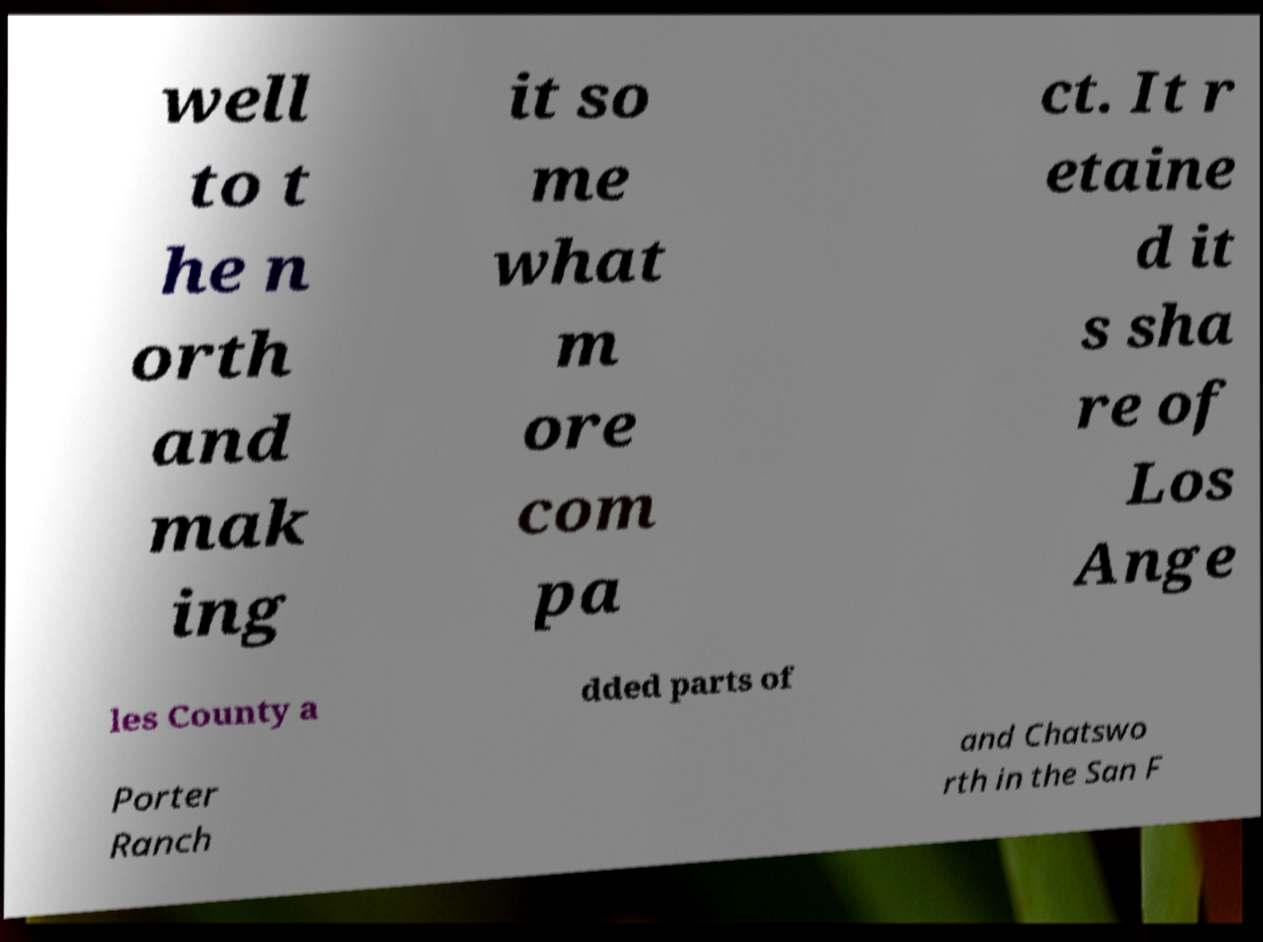Can you accurately transcribe the text from the provided image for me? well to t he n orth and mak ing it so me what m ore com pa ct. It r etaine d it s sha re of Los Ange les County a dded parts of Porter Ranch and Chatswo rth in the San F 